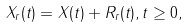Convert formula to latex. <formula><loc_0><loc_0><loc_500><loc_500>X _ { r } ( t ) = X ( t ) + R _ { r } ( t ) , t \geq 0 ,</formula> 